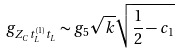<formula> <loc_0><loc_0><loc_500><loc_500>g _ { Z _ { C } t ^ { ( 1 ) } _ { L } t _ { L } } \sim { g _ { 5 } \sqrt { k } } \sqrt { \frac { 1 } { 2 } - c _ { 1 } }</formula> 